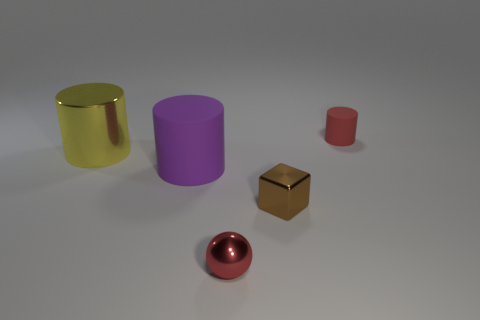Add 4 tiny spheres. How many objects exist? 9 Subtract all balls. How many objects are left? 4 Subtract all large red shiny cubes. Subtract all tiny brown blocks. How many objects are left? 4 Add 3 small shiny spheres. How many small shiny spheres are left? 4 Add 4 brown metal blocks. How many brown metal blocks exist? 5 Subtract 0 brown spheres. How many objects are left? 5 